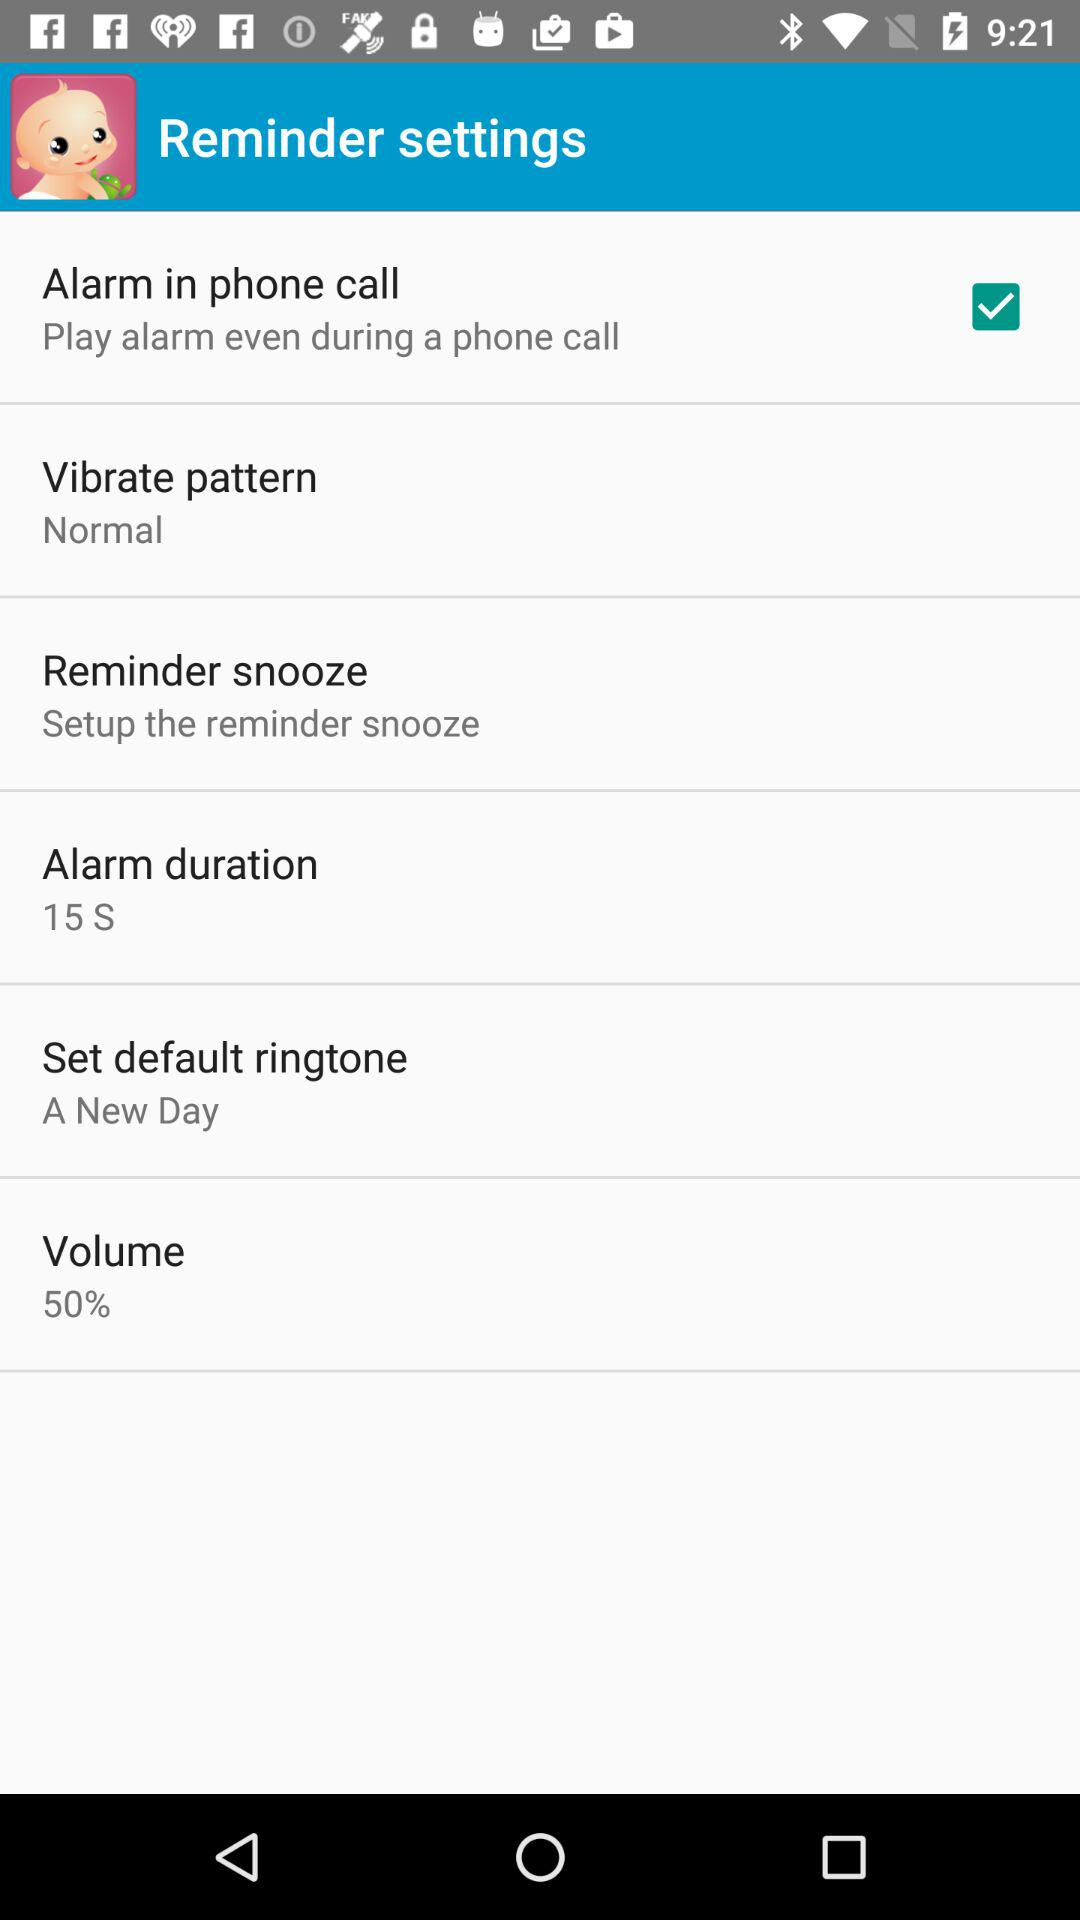How much is the alarm duration? The alarm duration is 15 seconds. 